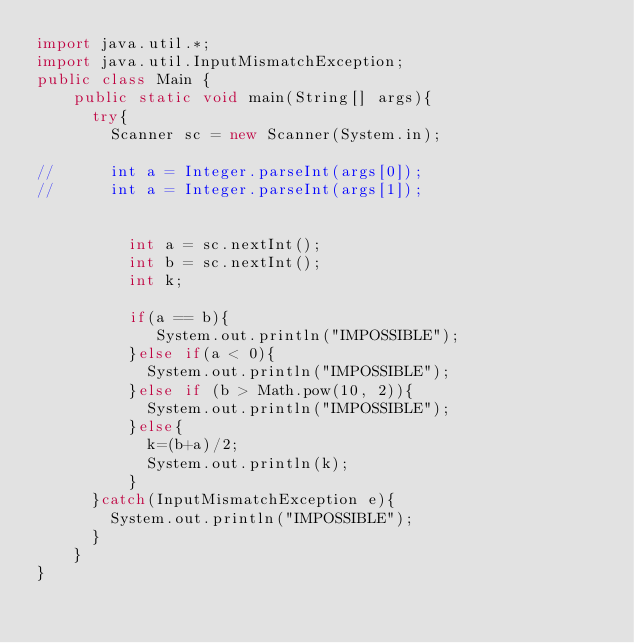<code> <loc_0><loc_0><loc_500><loc_500><_Java_>import java.util.*;
import java.util.InputMismatchException;
public class Main {
	public static void main(String[] args){
      try{
		Scanner sc = new Scanner(System.in);
      	
//      int a = Integer.parseInt(args[0]);
//      int a = Integer.parseInt(args[1]);

      
	      int a = sc.nextInt();
	      int b = sc.nextInt();
	      int k;
      
	      if(a == b){
 	  	     System.out.println("IMPOSSIBLE");
          }else if(a < 0){
            System.out.println("IMPOSSIBLE");
          }else if (b > Math.pow(10, 2)){
            System.out.println("IMPOSSIBLE");
	      }else{
	        k=(b+a)/2;
			System.out.println(k);
	      } 
      }catch(InputMismatchException e){
        System.out.println("IMPOSSIBLE");
      }
	}
}
</code> 